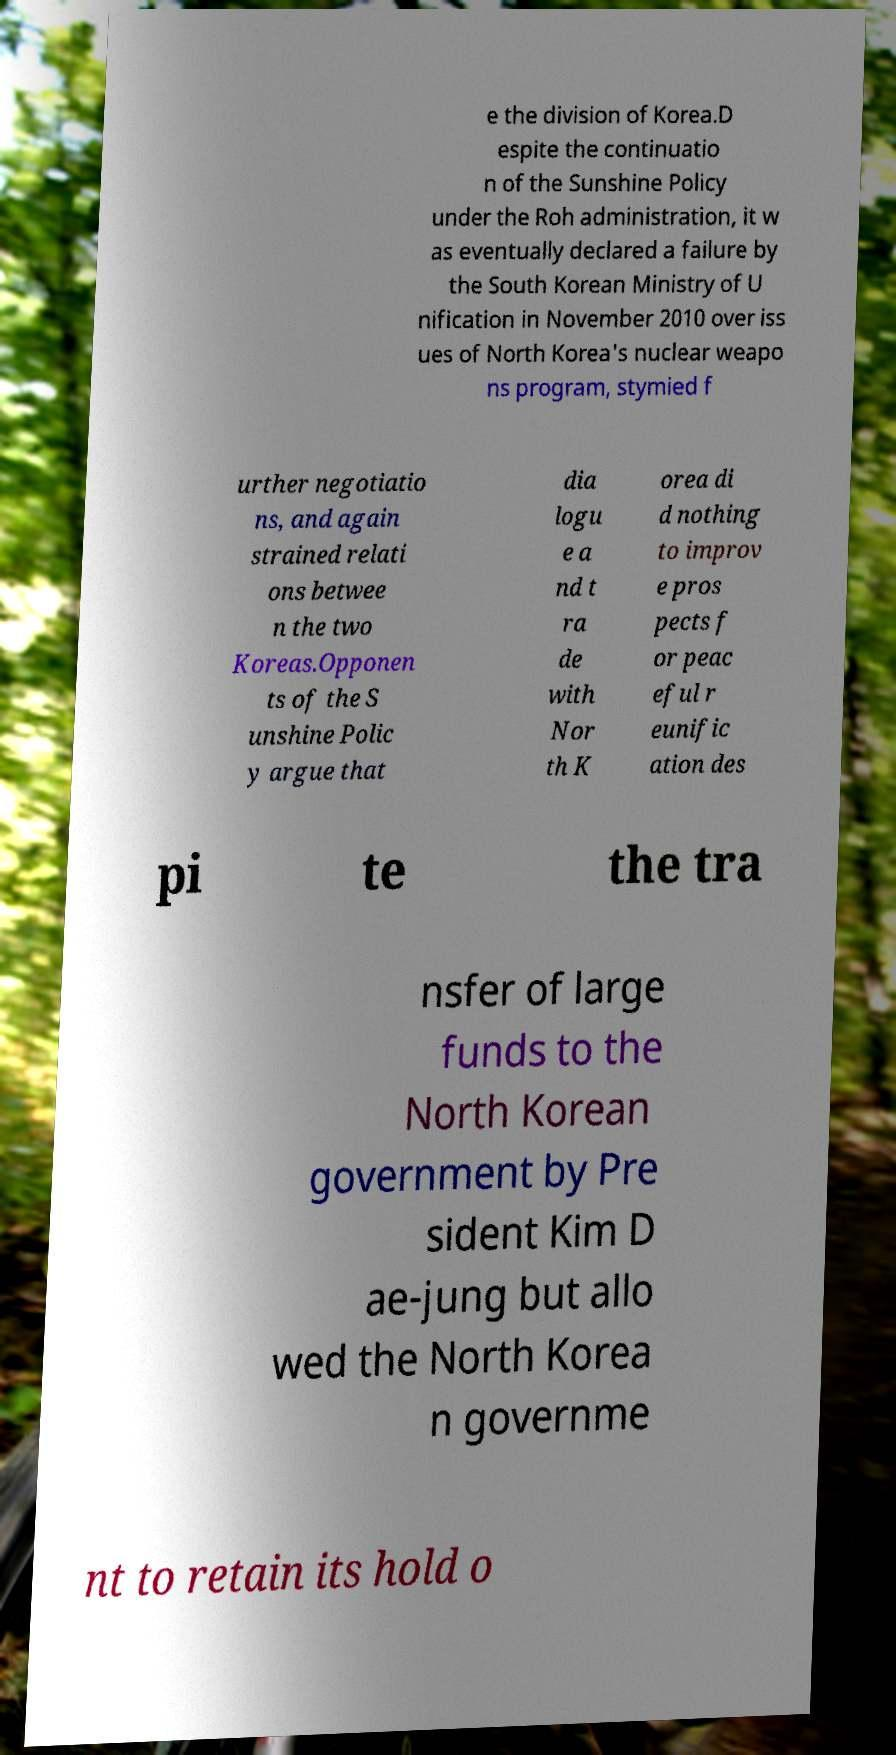Could you assist in decoding the text presented in this image and type it out clearly? e the division of Korea.D espite the continuatio n of the Sunshine Policy under the Roh administration, it w as eventually declared a failure by the South Korean Ministry of U nification in November 2010 over iss ues of North Korea's nuclear weapo ns program, stymied f urther negotiatio ns, and again strained relati ons betwee n the two Koreas.Opponen ts of the S unshine Polic y argue that dia logu e a nd t ra de with Nor th K orea di d nothing to improv e pros pects f or peac eful r eunific ation des pi te the tra nsfer of large funds to the North Korean government by Pre sident Kim D ae-jung but allo wed the North Korea n governme nt to retain its hold o 